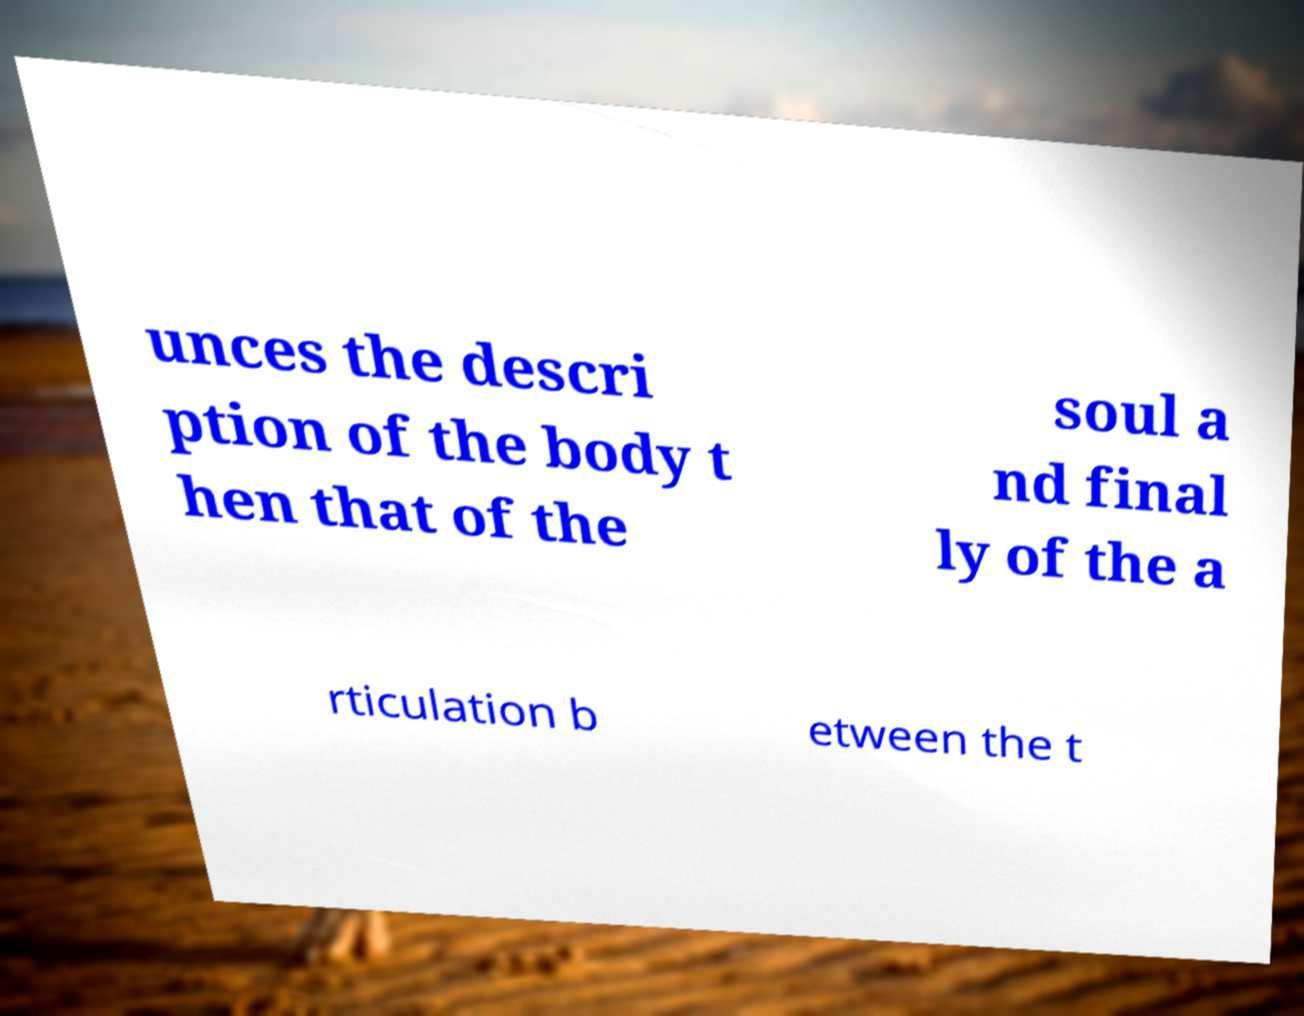For documentation purposes, I need the text within this image transcribed. Could you provide that? unces the descri ption of the body t hen that of the soul a nd final ly of the a rticulation b etween the t 